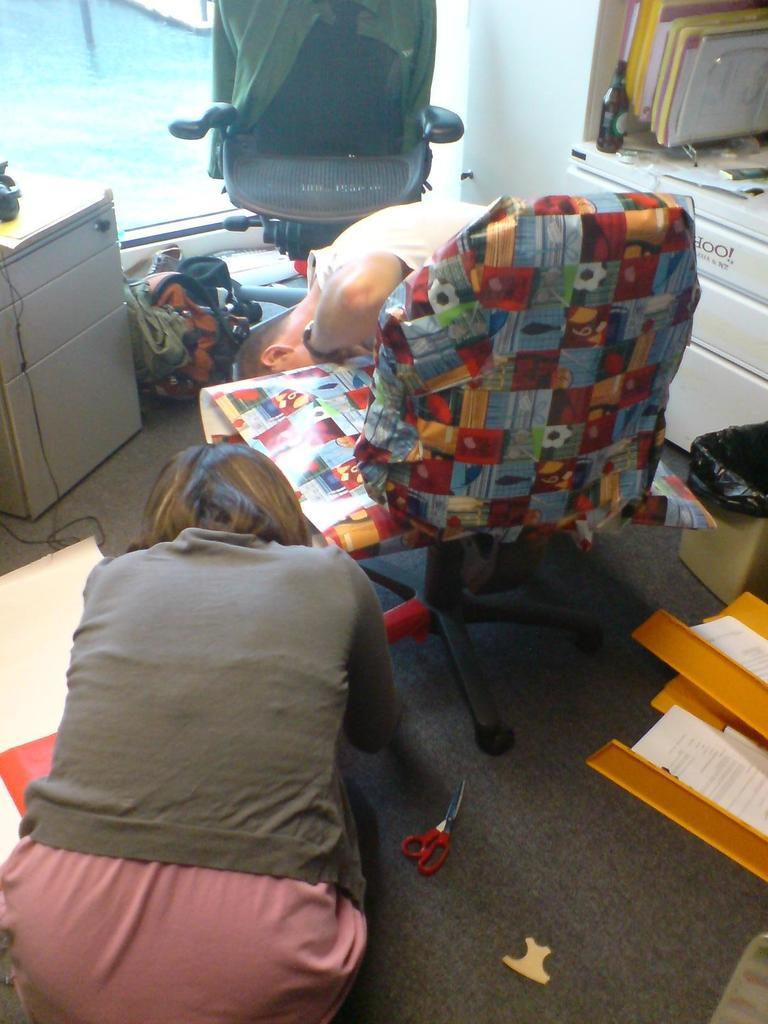How many chairs are in the image? There are two chairs in the image. How many people are in the image? There are two people in the image. What objects can be seen in the image besides the chairs and people? There are books and a scissors in the image. What does the grandfather say while laughing at the things in the image? There is no mention of a grandfather or laughter in the image, and therefore no such conversation can be observed. 